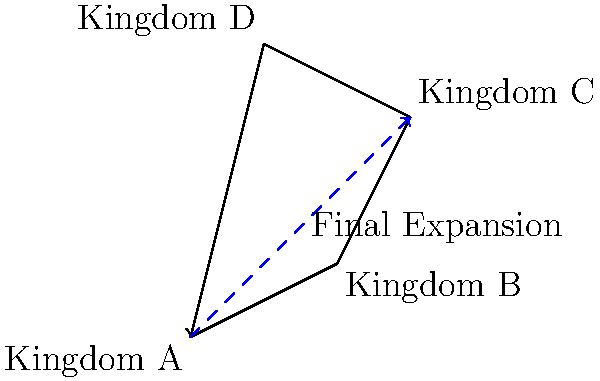A medieval kingdom expands its territory over three generations. The initial expansion is represented by the vector from Kingdom A to Kingdom B, followed by expansions to Kingdom C and then to Kingdom D. If each unit on the grid represents 100 km, what is the magnitude of the vector representing the overall expansion from Kingdom A to Kingdom D? To solve this problem, we'll use vector addition to find the overall expansion vector, then calculate its magnitude.

Step 1: Identify the individual expansion vectors
- A to B: $\vec{v_1} = (2,1)$
- B to C: $\vec{v_2} = (1,2)$
- C to D: $\vec{v_3} = (-2,1)$

Step 2: Add the vectors to find the overall expansion vector
$\vec{v_{total}} = \vec{v_1} + \vec{v_2} + \vec{v_3}$
$\vec{v_{total}} = (2,1) + (1,2) + (-2,1)$
$\vec{v_{total}} = (1,4)$

Step 3: Calculate the magnitude of the total vector
Magnitude = $\sqrt{x^2 + y^2}$
$|\vec{v_{total}}| = \sqrt{1^2 + 4^2} = \sqrt{1 + 16} = \sqrt{17}$

Step 4: Convert to kilometers
Each unit represents 100 km, so the final distance is:
$\sqrt{17} * 100 = 100\sqrt{17}$ km
Answer: $100\sqrt{17}$ km 